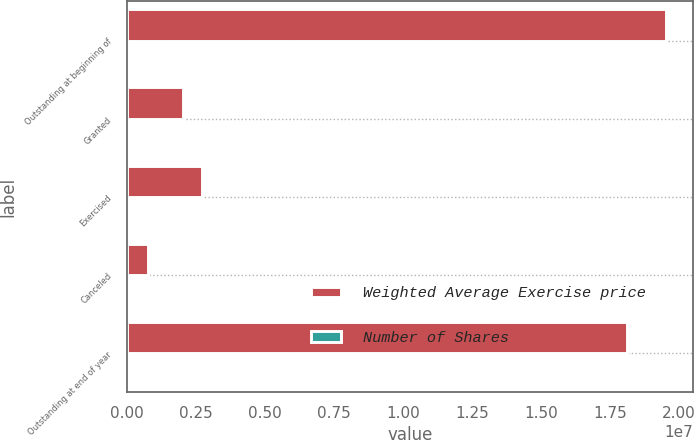Convert chart to OTSL. <chart><loc_0><loc_0><loc_500><loc_500><stacked_bar_chart><ecel><fcel>Outstanding at beginning of<fcel>Granted<fcel>Exercised<fcel>Canceled<fcel>Outstanding at end of year<nl><fcel>Weighted Average Exercise price<fcel>1.9537e+07<fcel>2.05139e+06<fcel>2.71864e+06<fcel>764825<fcel>1.81049e+07<nl><fcel>Number of Shares<fcel>26.19<fcel>33.54<fcel>22.36<fcel>34.02<fcel>27.27<nl></chart> 